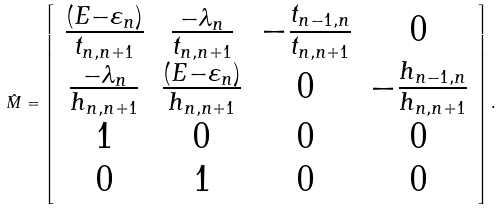Convert formula to latex. <formula><loc_0><loc_0><loc_500><loc_500>\hat { M } = \left [ \begin{array} { c c c c } \frac { ( E - \varepsilon _ { n } ) } { t _ { n , n + 1 } } & \frac { - \lambda _ { n } } { t _ { n , n + 1 } } & - \frac { t _ { n - 1 , n } } { t _ { n , n + 1 } } & 0 \\ \frac { - \lambda _ { n } } { h _ { n , n + 1 } } & \frac { ( E - \varepsilon _ { n } ) } { h _ { n , n + 1 } } & 0 & - \frac { h _ { n - 1 , n } } { h _ { n , n + 1 } } \\ 1 & 0 & 0 & 0 \\ 0 & 1 & 0 & 0 \end{array} \right ] .</formula> 